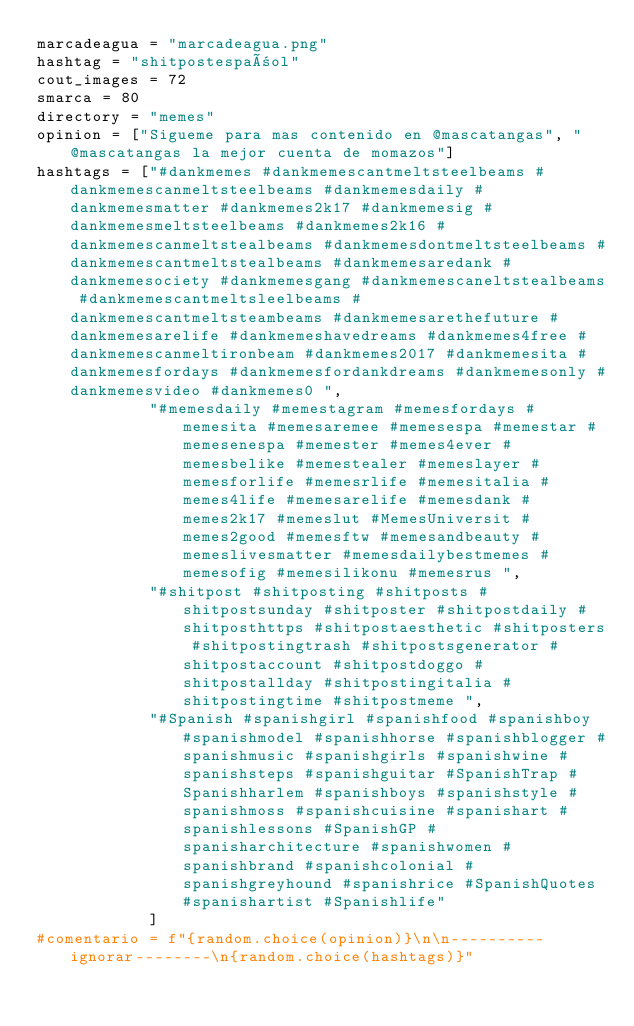Convert code to text. <code><loc_0><loc_0><loc_500><loc_500><_Python_>marcadeagua = "marcadeagua.png"
hashtag = "shitpostespañol"
cout_images = 72
smarca = 80
directory = "memes"
opinion = ["Sigueme para mas contenido en @mascatangas", "@mascatangas la mejor cuenta de momazos"]
hashtags = ["#dankmemes #dankmemescantmeltsteelbeams #dankmemescanmeltsteelbeams #dankmemesdaily #dankmemesmatter #dankmemes2k17 #dankmemesig #dankmemesmeltsteelbeams #dankmemes2k16 #dankmemescanmeltstealbeams #dankmemesdontmeltsteelbeams #dankmemescantmeltstealbeams #dankmemesaredank #dankmemesociety #dankmemesgang #dankmemescaneltstealbeams #dankmemescantmeltsleelbeams #dankmemescantmeltsteambeams #dankmemesarethefuture #dankmemesarelife #dankmemeshavedreams #dankmemes4free #dankmemescanmeltironbeam #dankmemes2017 #dankmemesita #dankmemesfordays #dankmemesfordankdreams #dankmemesonly #dankmemesvideo #dankmemes0 ",
            "#memesdaily #memestagram #memesfordays #memesita #memesaremee #memesespa #memestar #memesenespa #memester #memes4ever #memesbelike #memestealer #memeslayer #memesforlife #memesrlife #memesitalia #memes4life #memesarelife #memesdank #memes2k17 #memeslut #MemesUniversit #memes2good #memesftw #memesandbeauty #memeslivesmatter #memesdailybestmemes #memesofig #memesilikonu #memesrus ",
            "#shitpost #shitposting #shitposts #shitpostsunday #shitposter #shitpostdaily #shitposthttps #shitpostaesthetic #shitposters #shitpostingtrash #shitpostsgenerator #shitpostaccount #shitpostdoggo #shitpostallday #shitpostingitalia #shitpostingtime #shitpostmeme ",
            "#Spanish #spanishgirl #spanishfood #spanishboy #spanishmodel #spanishhorse #spanishblogger #spanishmusic #spanishgirls #spanishwine #spanishsteps #spanishguitar #SpanishTrap #Spanishharlem #spanishboys #spanishstyle #spanishmoss #spanishcuisine #spanishart #spanishlessons #SpanishGP #spanisharchitecture #spanishwomen #spanishbrand #spanishcolonial #spanishgreyhound #spanishrice #SpanishQuotes #spanishartist #Spanishlife"
            ]
#comentario = f"{random.choice(opinion)}\n\n----------ignorar--------\n{random.choice(hashtags)}"
</code> 